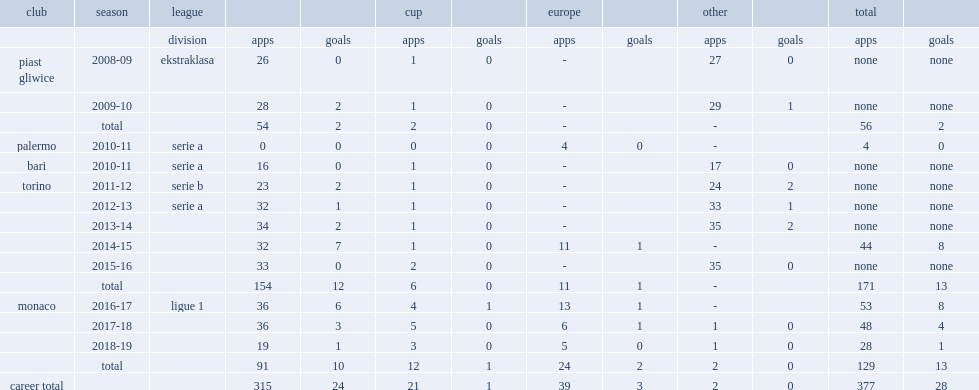How many games did kamil glik play with 13 goals fr torino in total? 171.0. 